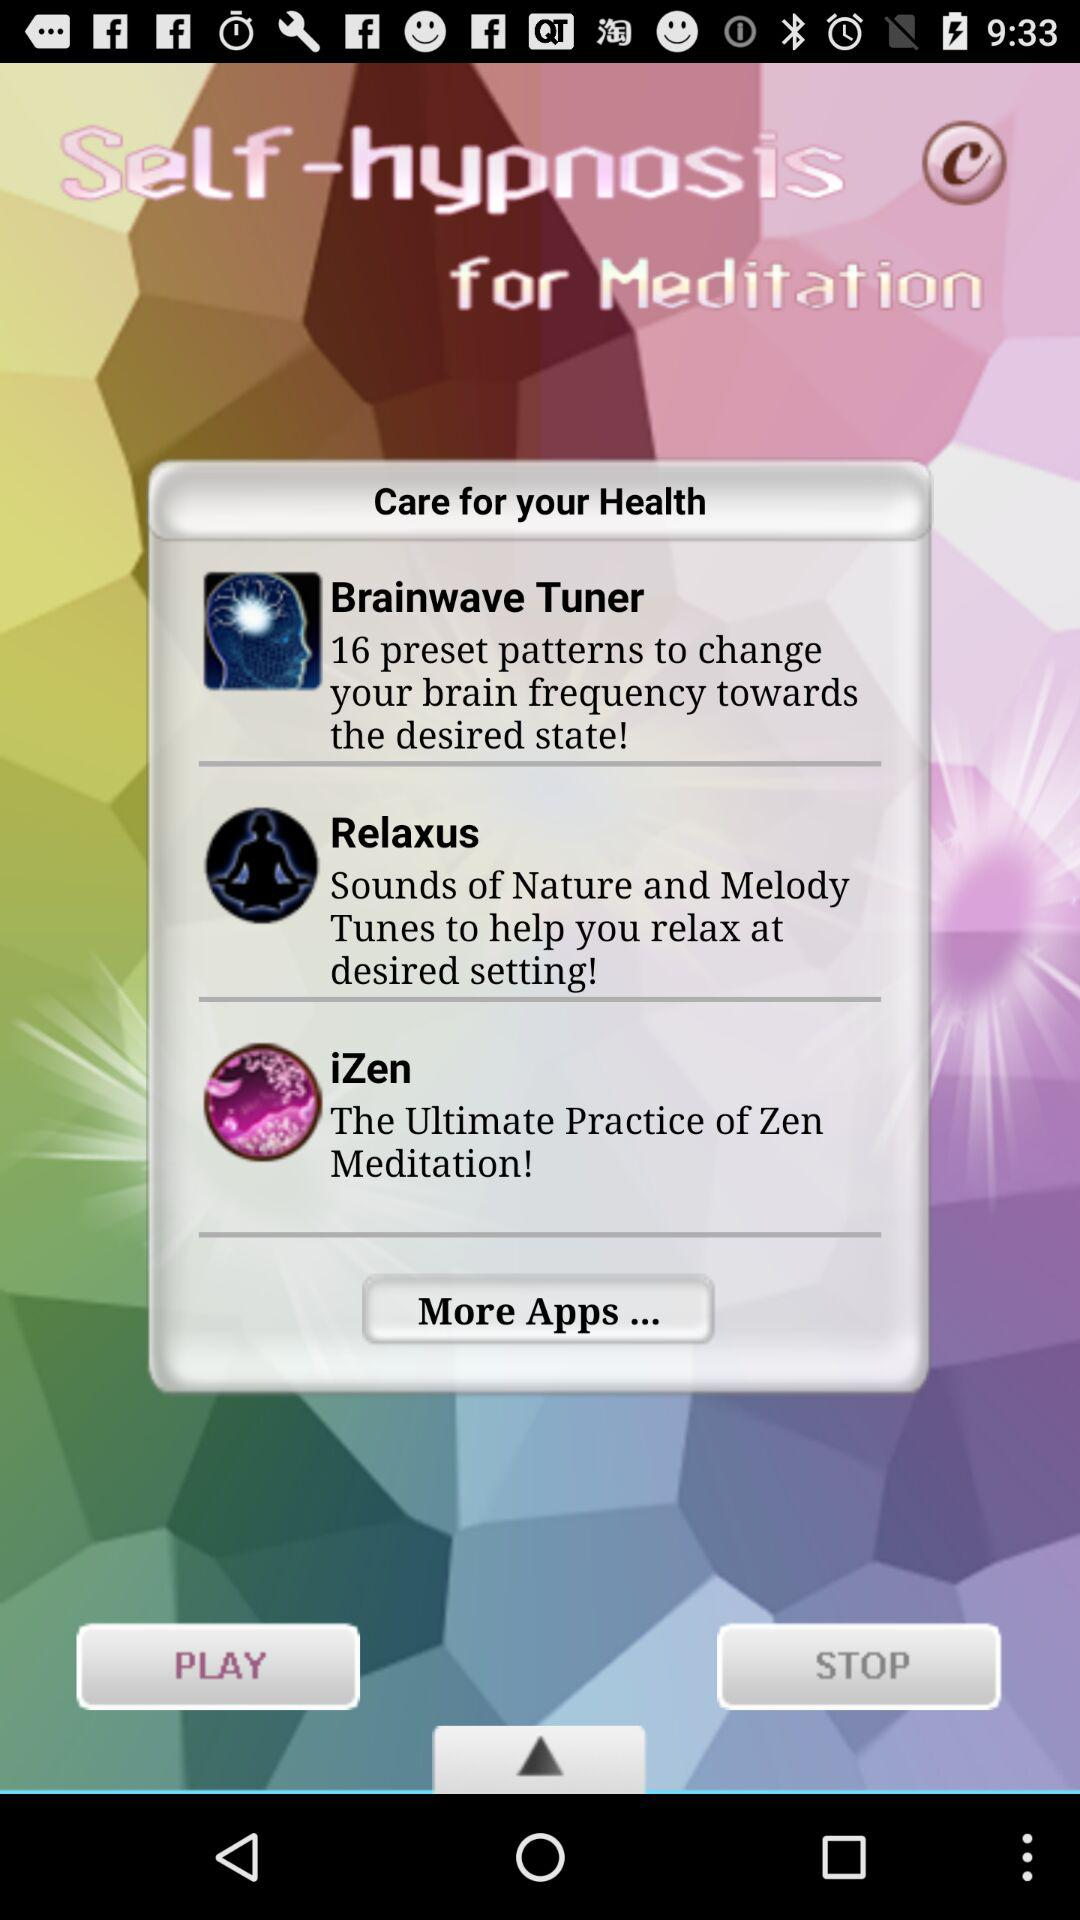How many apps are available?
Answer the question using a single word or phrase. 3 